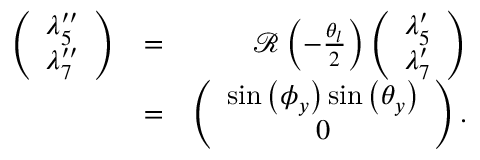<formula> <loc_0><loc_0><loc_500><loc_500>\begin{array} { r l r } { \left ( \begin{array} { c } { \lambda _ { 5 } ^ { \prime \prime } } \\ { \lambda _ { 7 } ^ { \prime \prime } } \end{array} \right ) } & { = } & { { \mathcal { R } } \left ( - \frac { \theta _ { l } } { 2 } \right ) \left ( \begin{array} { c } { \lambda _ { 5 } ^ { \prime } } \\ { \lambda _ { 7 } ^ { \prime } } \end{array} \right ) } \\ & { = } & { \left ( \begin{array} { c } { \sin \left ( \phi _ { y } \right ) \sin \left ( \theta _ { y } \right ) } \\ { 0 } \end{array} \right ) . } \end{array}</formula> 